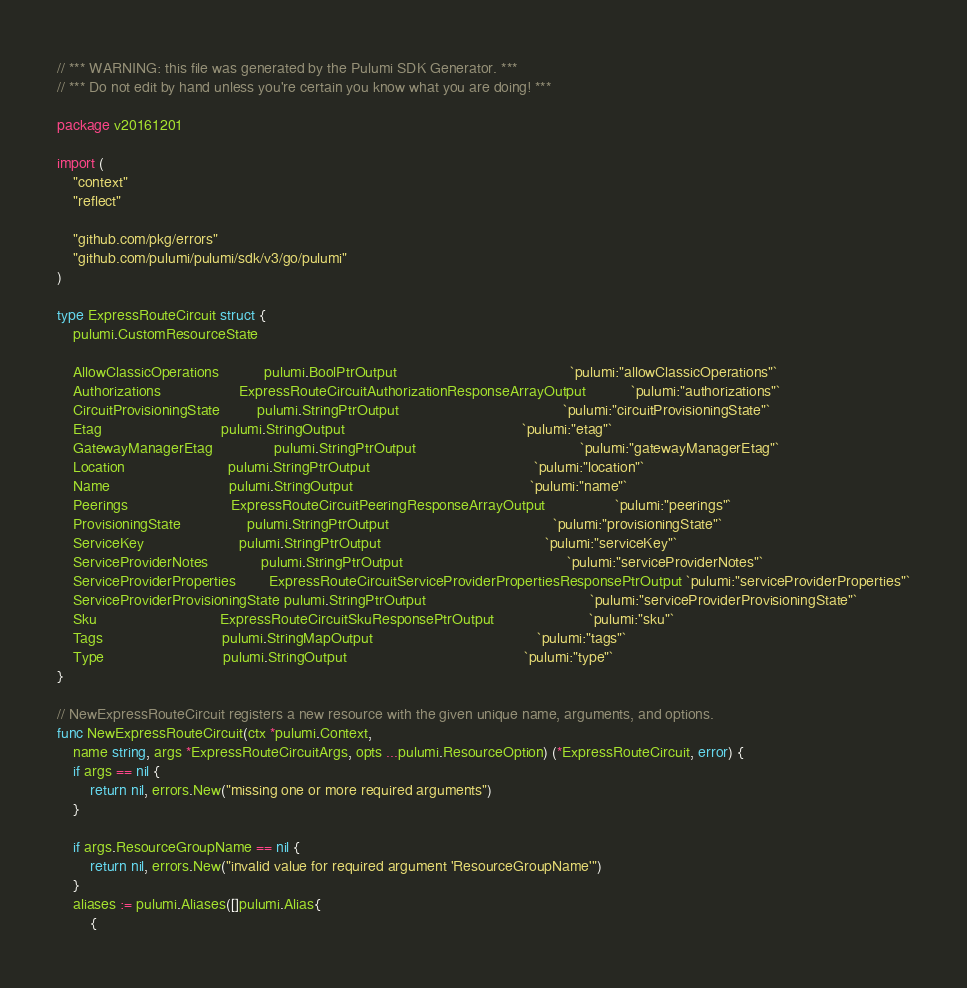Convert code to text. <code><loc_0><loc_0><loc_500><loc_500><_Go_>// *** WARNING: this file was generated by the Pulumi SDK Generator. ***
// *** Do not edit by hand unless you're certain you know what you are doing! ***

package v20161201

import (
	"context"
	"reflect"

	"github.com/pkg/errors"
	"github.com/pulumi/pulumi/sdk/v3/go/pulumi"
)

type ExpressRouteCircuit struct {
	pulumi.CustomResourceState

	AllowClassicOperations           pulumi.BoolPtrOutput                                          `pulumi:"allowClassicOperations"`
	Authorizations                   ExpressRouteCircuitAuthorizationResponseArrayOutput           `pulumi:"authorizations"`
	CircuitProvisioningState         pulumi.StringPtrOutput                                        `pulumi:"circuitProvisioningState"`
	Etag                             pulumi.StringOutput                                           `pulumi:"etag"`
	GatewayManagerEtag               pulumi.StringPtrOutput                                        `pulumi:"gatewayManagerEtag"`
	Location                         pulumi.StringPtrOutput                                        `pulumi:"location"`
	Name                             pulumi.StringOutput                                           `pulumi:"name"`
	Peerings                         ExpressRouteCircuitPeeringResponseArrayOutput                 `pulumi:"peerings"`
	ProvisioningState                pulumi.StringPtrOutput                                        `pulumi:"provisioningState"`
	ServiceKey                       pulumi.StringPtrOutput                                        `pulumi:"serviceKey"`
	ServiceProviderNotes             pulumi.StringPtrOutput                                        `pulumi:"serviceProviderNotes"`
	ServiceProviderProperties        ExpressRouteCircuitServiceProviderPropertiesResponsePtrOutput `pulumi:"serviceProviderProperties"`
	ServiceProviderProvisioningState pulumi.StringPtrOutput                                        `pulumi:"serviceProviderProvisioningState"`
	Sku                              ExpressRouteCircuitSkuResponsePtrOutput                       `pulumi:"sku"`
	Tags                             pulumi.StringMapOutput                                        `pulumi:"tags"`
	Type                             pulumi.StringOutput                                           `pulumi:"type"`
}

// NewExpressRouteCircuit registers a new resource with the given unique name, arguments, and options.
func NewExpressRouteCircuit(ctx *pulumi.Context,
	name string, args *ExpressRouteCircuitArgs, opts ...pulumi.ResourceOption) (*ExpressRouteCircuit, error) {
	if args == nil {
		return nil, errors.New("missing one or more required arguments")
	}

	if args.ResourceGroupName == nil {
		return nil, errors.New("invalid value for required argument 'ResourceGroupName'")
	}
	aliases := pulumi.Aliases([]pulumi.Alias{
		{</code> 